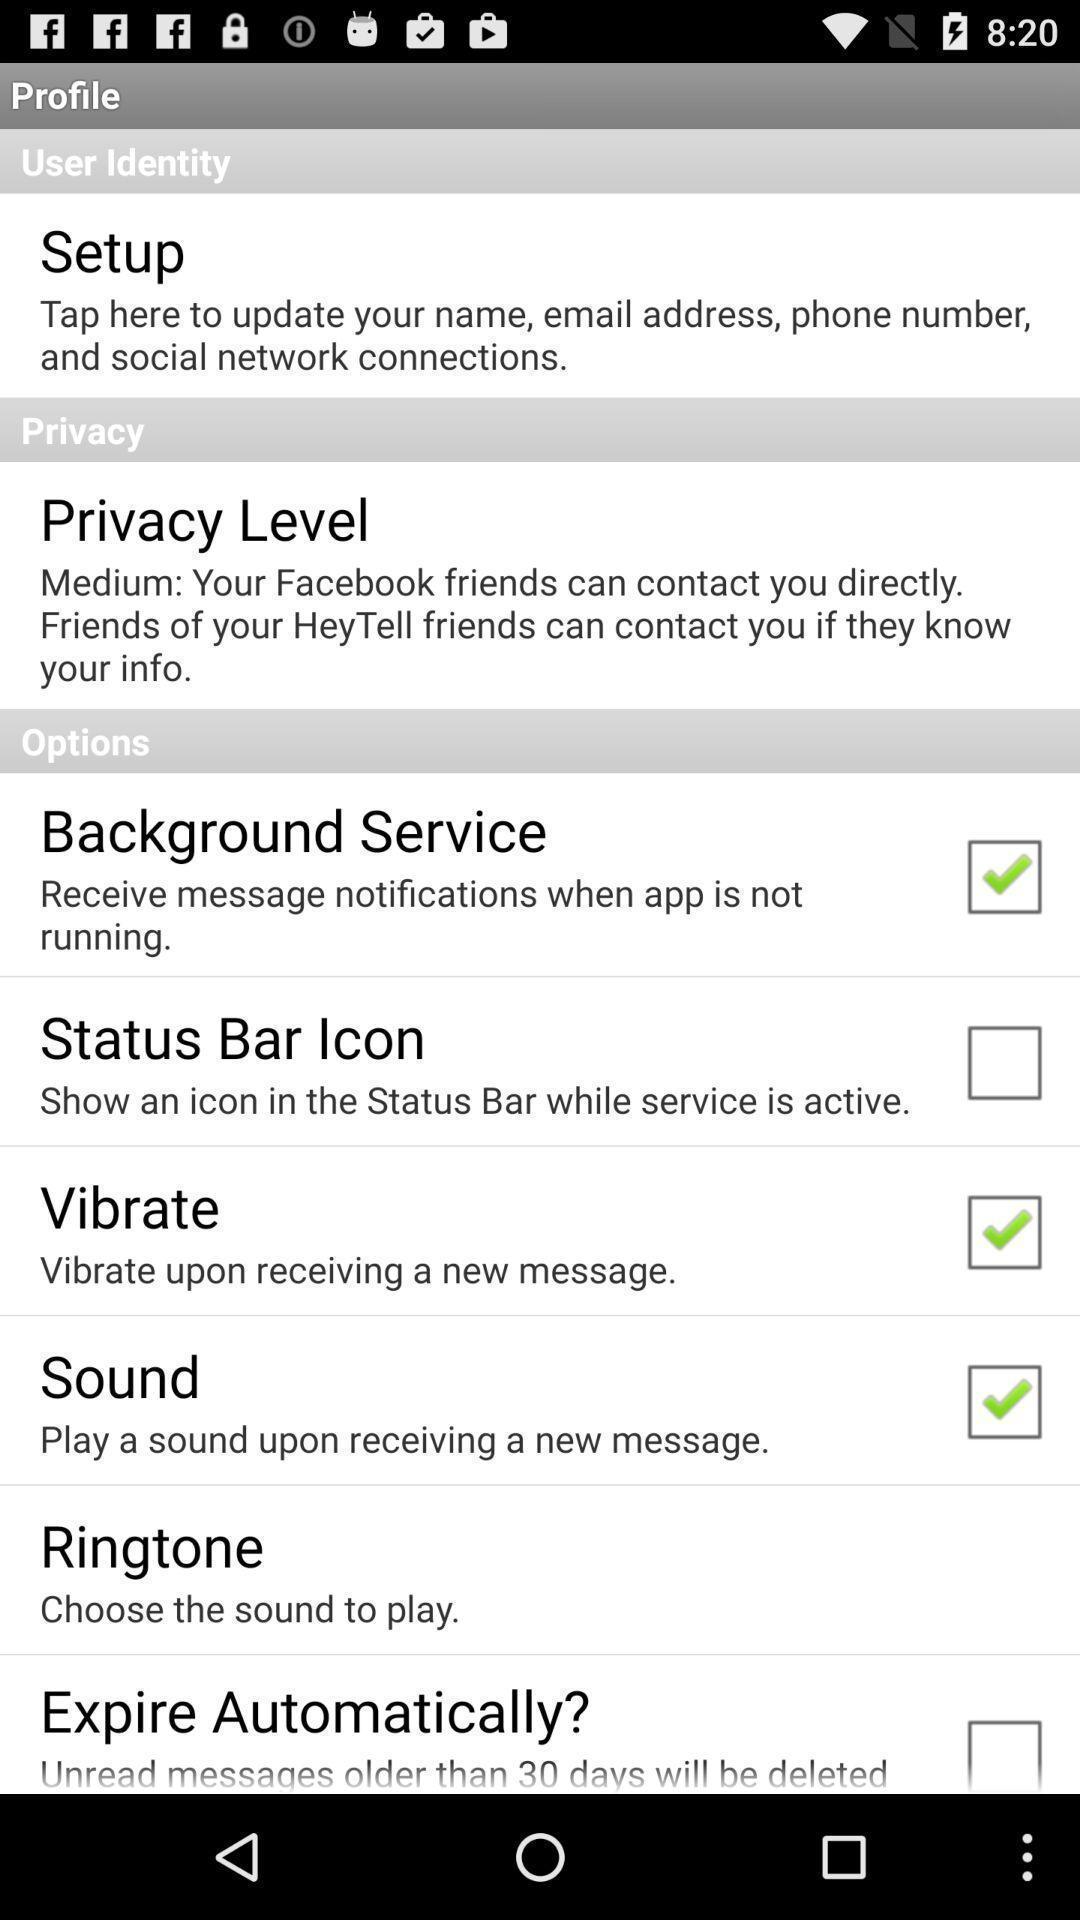Tell me about the visual elements in this screen capture. Profile menu page in a voice mailing app. 